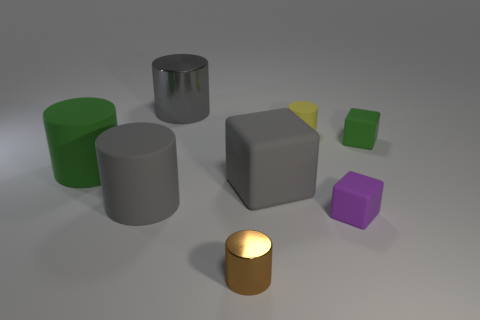What is the shape of the brown thing?
Provide a short and direct response. Cylinder. Is the material of the large green thing the same as the brown thing?
Provide a succinct answer. No. Is the number of tiny brown metal cylinders behind the big green rubber thing the same as the number of tiny blocks that are in front of the small green thing?
Your answer should be very brief. No. Are there any small brown shiny things to the left of the green rubber thing that is right of the shiny thing that is in front of the purple rubber thing?
Keep it short and to the point. Yes. Do the purple rubber object and the yellow rubber cylinder have the same size?
Offer a very short reply. Yes. What color is the shiny cylinder behind the tiny cylinder that is behind the small thing left of the tiny matte cylinder?
Ensure brevity in your answer.  Gray. What number of cylinders have the same color as the large rubber block?
Provide a short and direct response. 2. What number of small things are either green cubes or yellow cylinders?
Make the answer very short. 2. Are there any yellow matte things of the same shape as the brown metal thing?
Offer a very short reply. Yes. Is the brown metallic object the same shape as the tiny green matte thing?
Your answer should be compact. No. 